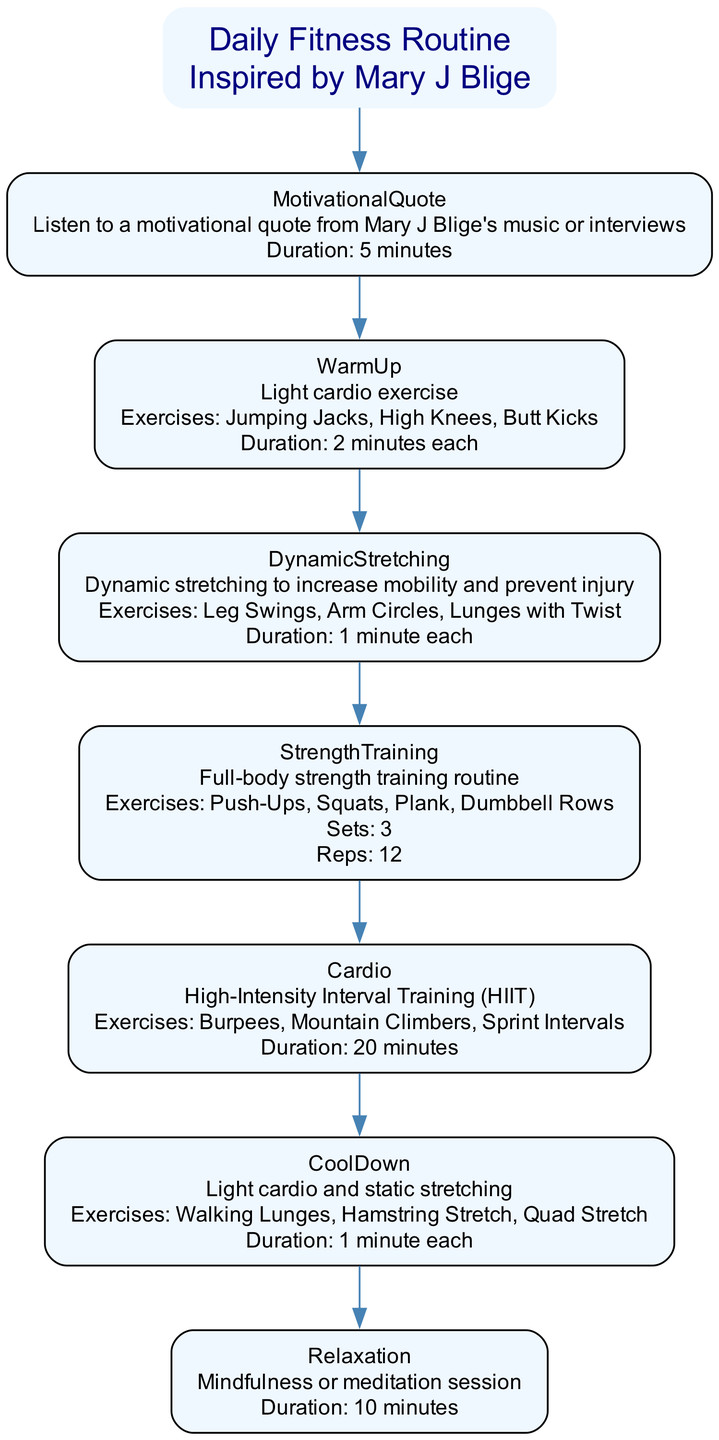What is the first activity in the fitness routine? The first step listed in the diagram is "MotivationalQuote" which involves listening to a motivational quote from Mary J Blige's music or interviews for 5 minutes.
Answer: MotivationalQuote How many exercises are included in the dynamic stretching step? The dynamic stretching step lists three exercises: Leg Swings, Arm Circles, and Lunges with Twist. Therefore, there are three exercises in this step.
Answer: 3 What is the total duration of the strength training routine? The strength training step indicates that there are 12 reps per set and 3 sets. It does not state the specific duration, but when considered with the preceding warm-up and stretching, the time spent is shorter. Hence, the duration cannot be computed directly from the info given.
Answer: Not computable (duration not specified) What activity is performed after CoolDown? The diagram flows from CoolDown to the next step labeled "Relaxation," which involves mindfulness or meditation techniques.
Answer: Relaxation Which type of workout is prescribed after WarmUp? The diagram indicates that after WarmUp, the step is "DynamicStretching," which aims to increase mobility and prevent injury.
Answer: DynamicStretching How long is the HIIT cardio workout? The diagram specifies that the High-Intensity Interval Training (HIIT) assigned for the cardio workout has a duration of 20 minutes.
Answer: 20 minutes What is the last repeated activity performed? The last repeated activity in the flowchart is "Relaxation," which involves a mindfulness or meditation session.
Answer: Relaxation Which exercise is performed in the strength training routine? The strength training routine consists of several exercises, and one of them is "Push-Ups," as stated in the diagram.
Answer: Push-Ups What is the total duration allocated for the entire fitness routine, excluding the exercises’ internal durations? The total of the explicitly stated durations is 5 minutes (MotivationalQuote) + 20 minutes (Cardio) + 10 minutes (Relaxation), which totals 35 minutes.
Answer: 35 minutes 